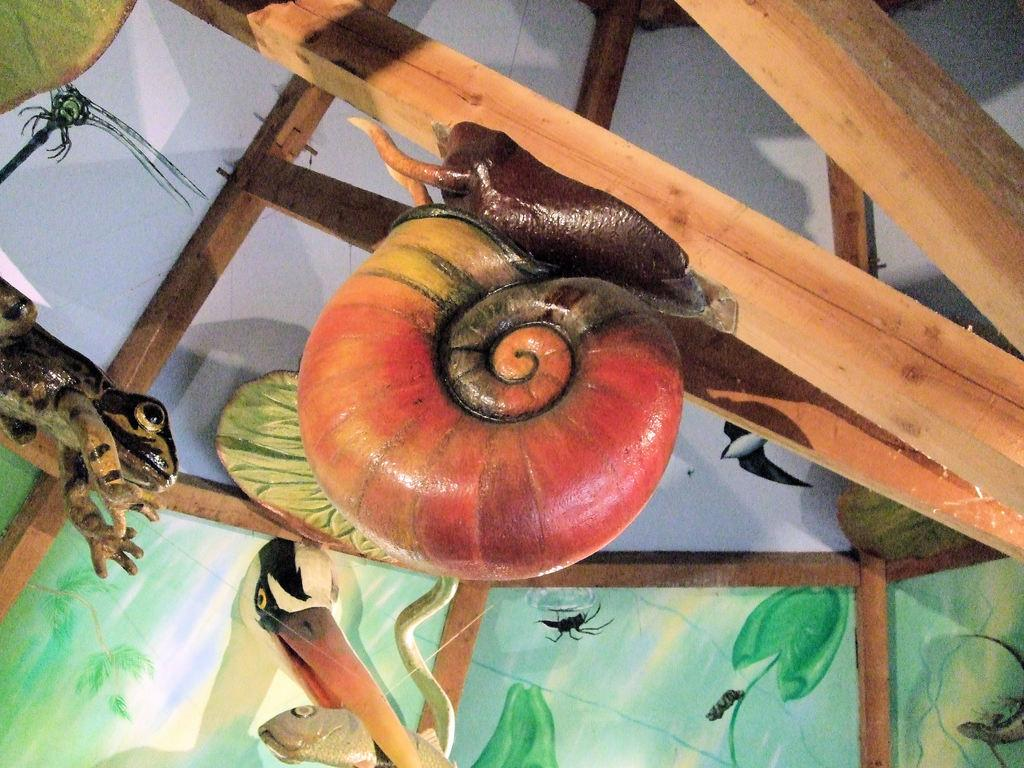What type of toy is on a wooden stick in the image? There is a snail toy on a wooden stick in the image. What is the wooden stick connected to? The wooden stick appears to be part of a roof. What other toys can be seen in the image? There are animal toys on wooden sticks at the bottom of the image. What type of ray is visible in the image? There is no ray present in the image. What type of system is being used to display the toys in the image? The image does not show a specific system for displaying the toys; it simply shows the toys on wooden sticks. 